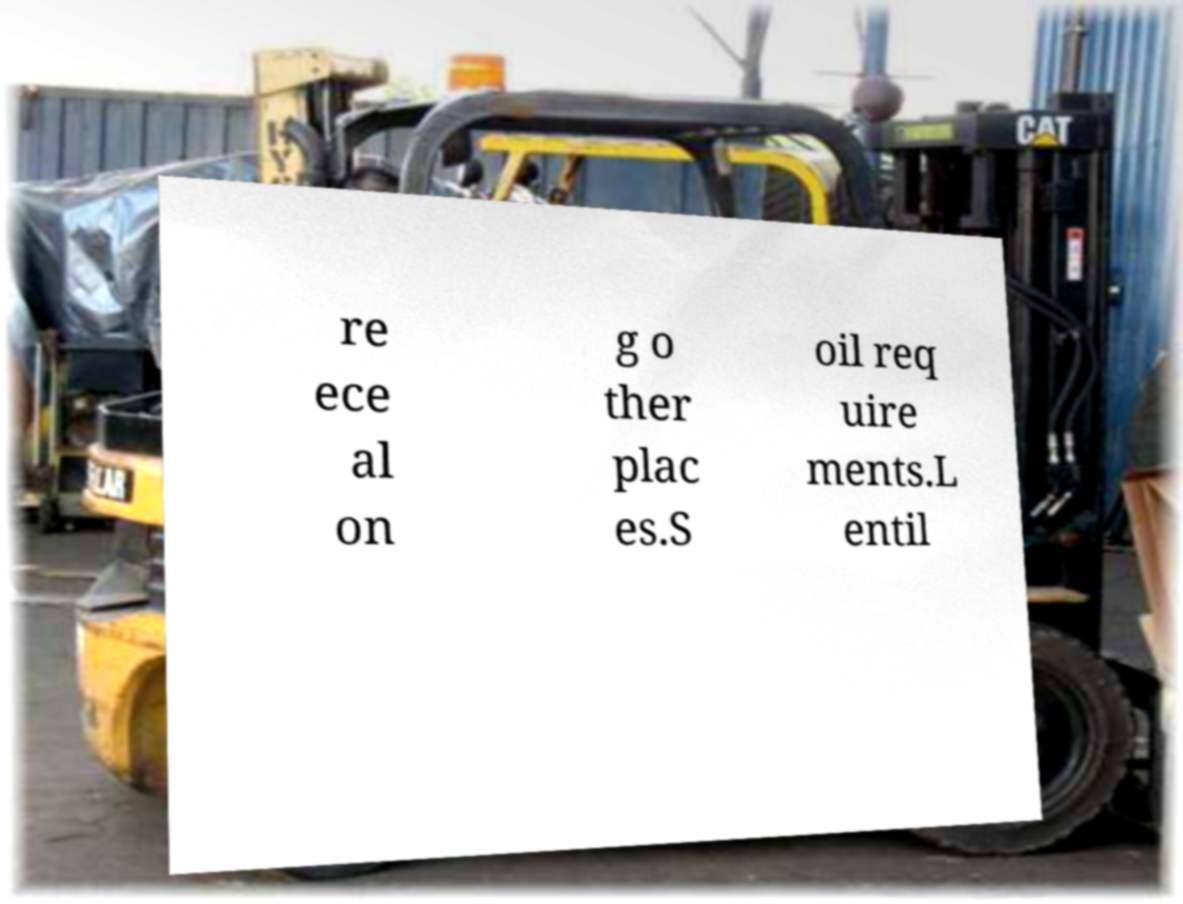Please identify and transcribe the text found in this image. re ece al on g o ther plac es.S oil req uire ments.L entil 